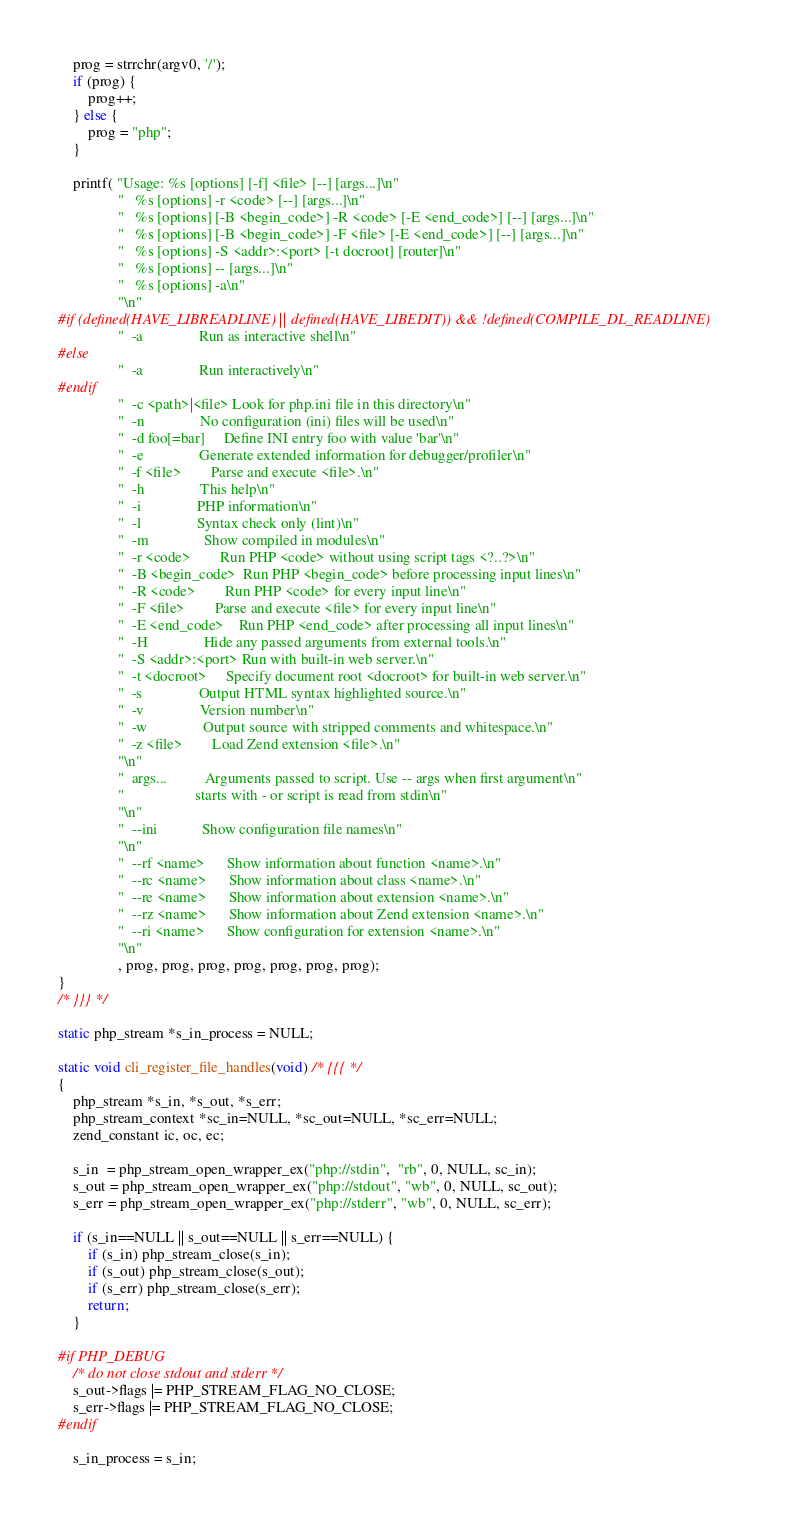Convert code to text. <code><loc_0><loc_0><loc_500><loc_500><_C_>
	prog = strrchr(argv0, '/');
	if (prog) {
		prog++;
	} else {
		prog = "php";
	}

	printf( "Usage: %s [options] [-f] <file> [--] [args...]\n"
				"   %s [options] -r <code> [--] [args...]\n"
				"   %s [options] [-B <begin_code>] -R <code> [-E <end_code>] [--] [args...]\n"
				"   %s [options] [-B <begin_code>] -F <file> [-E <end_code>] [--] [args...]\n"
				"   %s [options] -S <addr>:<port> [-t docroot] [router]\n"
				"   %s [options] -- [args...]\n"
				"   %s [options] -a\n"
				"\n"
#if (defined(HAVE_LIBREADLINE) || defined(HAVE_LIBEDIT)) && !defined(COMPILE_DL_READLINE)
				"  -a               Run as interactive shell\n"
#else
				"  -a               Run interactively\n"
#endif
				"  -c <path>|<file> Look for php.ini file in this directory\n"
				"  -n               No configuration (ini) files will be used\n"
				"  -d foo[=bar]     Define INI entry foo with value 'bar'\n"
				"  -e               Generate extended information for debugger/profiler\n"
				"  -f <file>        Parse and execute <file>.\n"
				"  -h               This help\n"
				"  -i               PHP information\n"
				"  -l               Syntax check only (lint)\n"
				"  -m               Show compiled in modules\n"
				"  -r <code>        Run PHP <code> without using script tags <?..?>\n"
				"  -B <begin_code>  Run PHP <begin_code> before processing input lines\n"
				"  -R <code>        Run PHP <code> for every input line\n"
				"  -F <file>        Parse and execute <file> for every input line\n"
				"  -E <end_code>    Run PHP <end_code> after processing all input lines\n"
				"  -H               Hide any passed arguments from external tools.\n"
				"  -S <addr>:<port> Run with built-in web server.\n"
				"  -t <docroot>     Specify document root <docroot> for built-in web server.\n"
				"  -s               Output HTML syntax highlighted source.\n"
				"  -v               Version number\n"
				"  -w               Output source with stripped comments and whitespace.\n"
				"  -z <file>        Load Zend extension <file>.\n"
				"\n"
				"  args...          Arguments passed to script. Use -- args when first argument\n"
				"                   starts with - or script is read from stdin\n"
				"\n"
				"  --ini            Show configuration file names\n"
				"\n"
				"  --rf <name>      Show information about function <name>.\n"
				"  --rc <name>      Show information about class <name>.\n"
				"  --re <name>      Show information about extension <name>.\n"
				"  --rz <name>      Show information about Zend extension <name>.\n"
				"  --ri <name>      Show configuration for extension <name>.\n"
				"\n"
				, prog, prog, prog, prog, prog, prog, prog);
}
/* }}} */

static php_stream *s_in_process = NULL;

static void cli_register_file_handles(void) /* {{{ */
{
	php_stream *s_in, *s_out, *s_err;
	php_stream_context *sc_in=NULL, *sc_out=NULL, *sc_err=NULL;
	zend_constant ic, oc, ec;

	s_in  = php_stream_open_wrapper_ex("php://stdin",  "rb", 0, NULL, sc_in);
	s_out = php_stream_open_wrapper_ex("php://stdout", "wb", 0, NULL, sc_out);
	s_err = php_stream_open_wrapper_ex("php://stderr", "wb", 0, NULL, sc_err);

	if (s_in==NULL || s_out==NULL || s_err==NULL) {
		if (s_in) php_stream_close(s_in);
		if (s_out) php_stream_close(s_out);
		if (s_err) php_stream_close(s_err);
		return;
	}

#if PHP_DEBUG
	/* do not close stdout and stderr */
	s_out->flags |= PHP_STREAM_FLAG_NO_CLOSE;
	s_err->flags |= PHP_STREAM_FLAG_NO_CLOSE;
#endif

	s_in_process = s_in;
</code> 